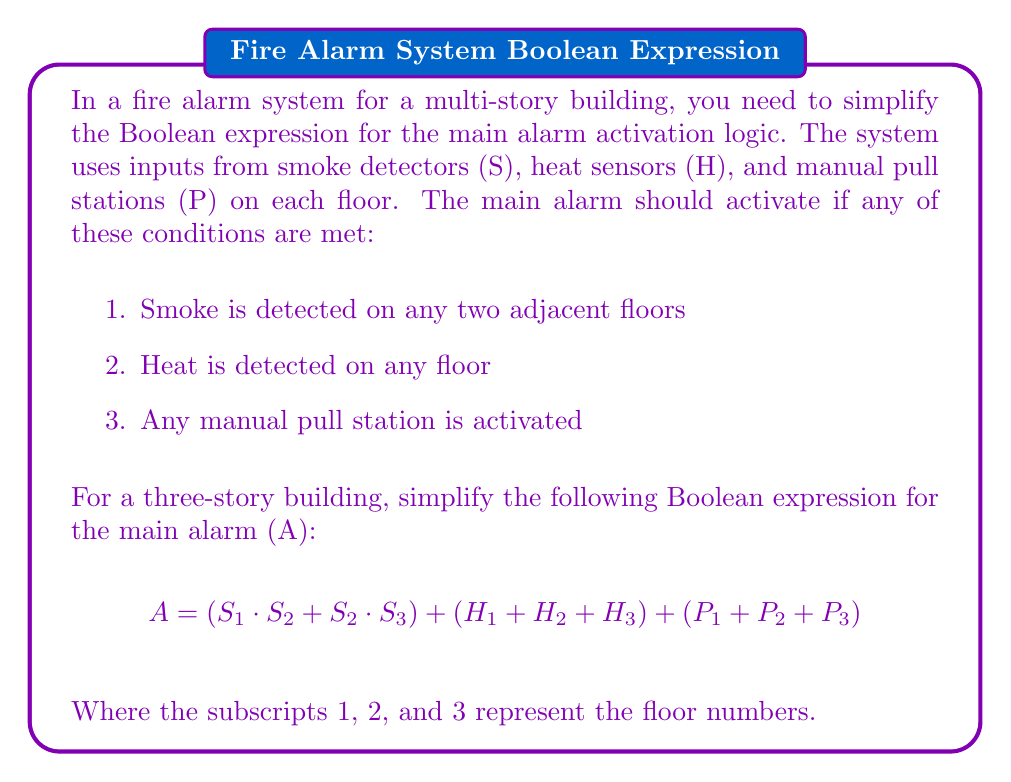Can you solve this math problem? Let's simplify this Boolean expression step by step:

1. First, let's group the terms:
   $$ A = (S_1 \cdot S_2 + S_2 \cdot S_3) + (H_1 + H_2 + H_3) + (P_1 + P_2 + P_3) $$

2. We can apply the distributive property to the first group:
   $$ A = S_2 \cdot (S_1 + S_3) + (H_1 + H_2 + H_3) + (P_1 + P_2 + P_3) $$

3. Now, we have three main terms connected by OR operations. In Boolean algebra, this means we can keep them as separate terms.

4. Let's define some new variables to simplify our expression:
   Let $S = S_2 \cdot (S_1 + S_3)$ (smoke detection on adjacent floors)
   Let $H = H_1 + H_2 + H_3$ (heat detection on any floor)
   Let $P = P_1 + P_2 + P_3$ (manual pull station activation on any floor)

5. Our simplified expression becomes:
   $$ A = S + H + P $$

This simplified form maintains the original logic while reducing the complexity of the expression. It clearly shows that the main alarm will activate if there's smoke on adjacent floors (S), heat on any floor (H), or a manual pull station is activated on any floor (P).
Answer: $$ A = S + H + P $$
Where:
$S = S_2 \cdot (S_1 + S_3)$
$H = H_1 + H_2 + H_3$
$P = P_1 + P_2 + P_3$ 